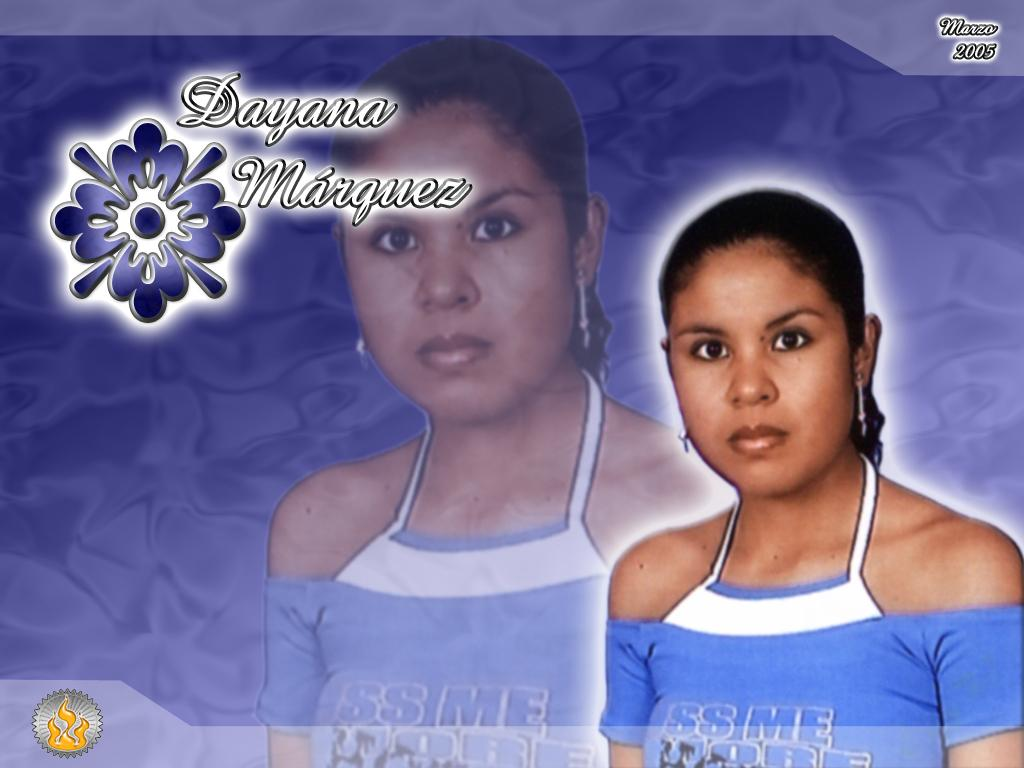<image>
Offer a succinct explanation of the picture presented. The year stated in the photograph with the girl is 2005. 